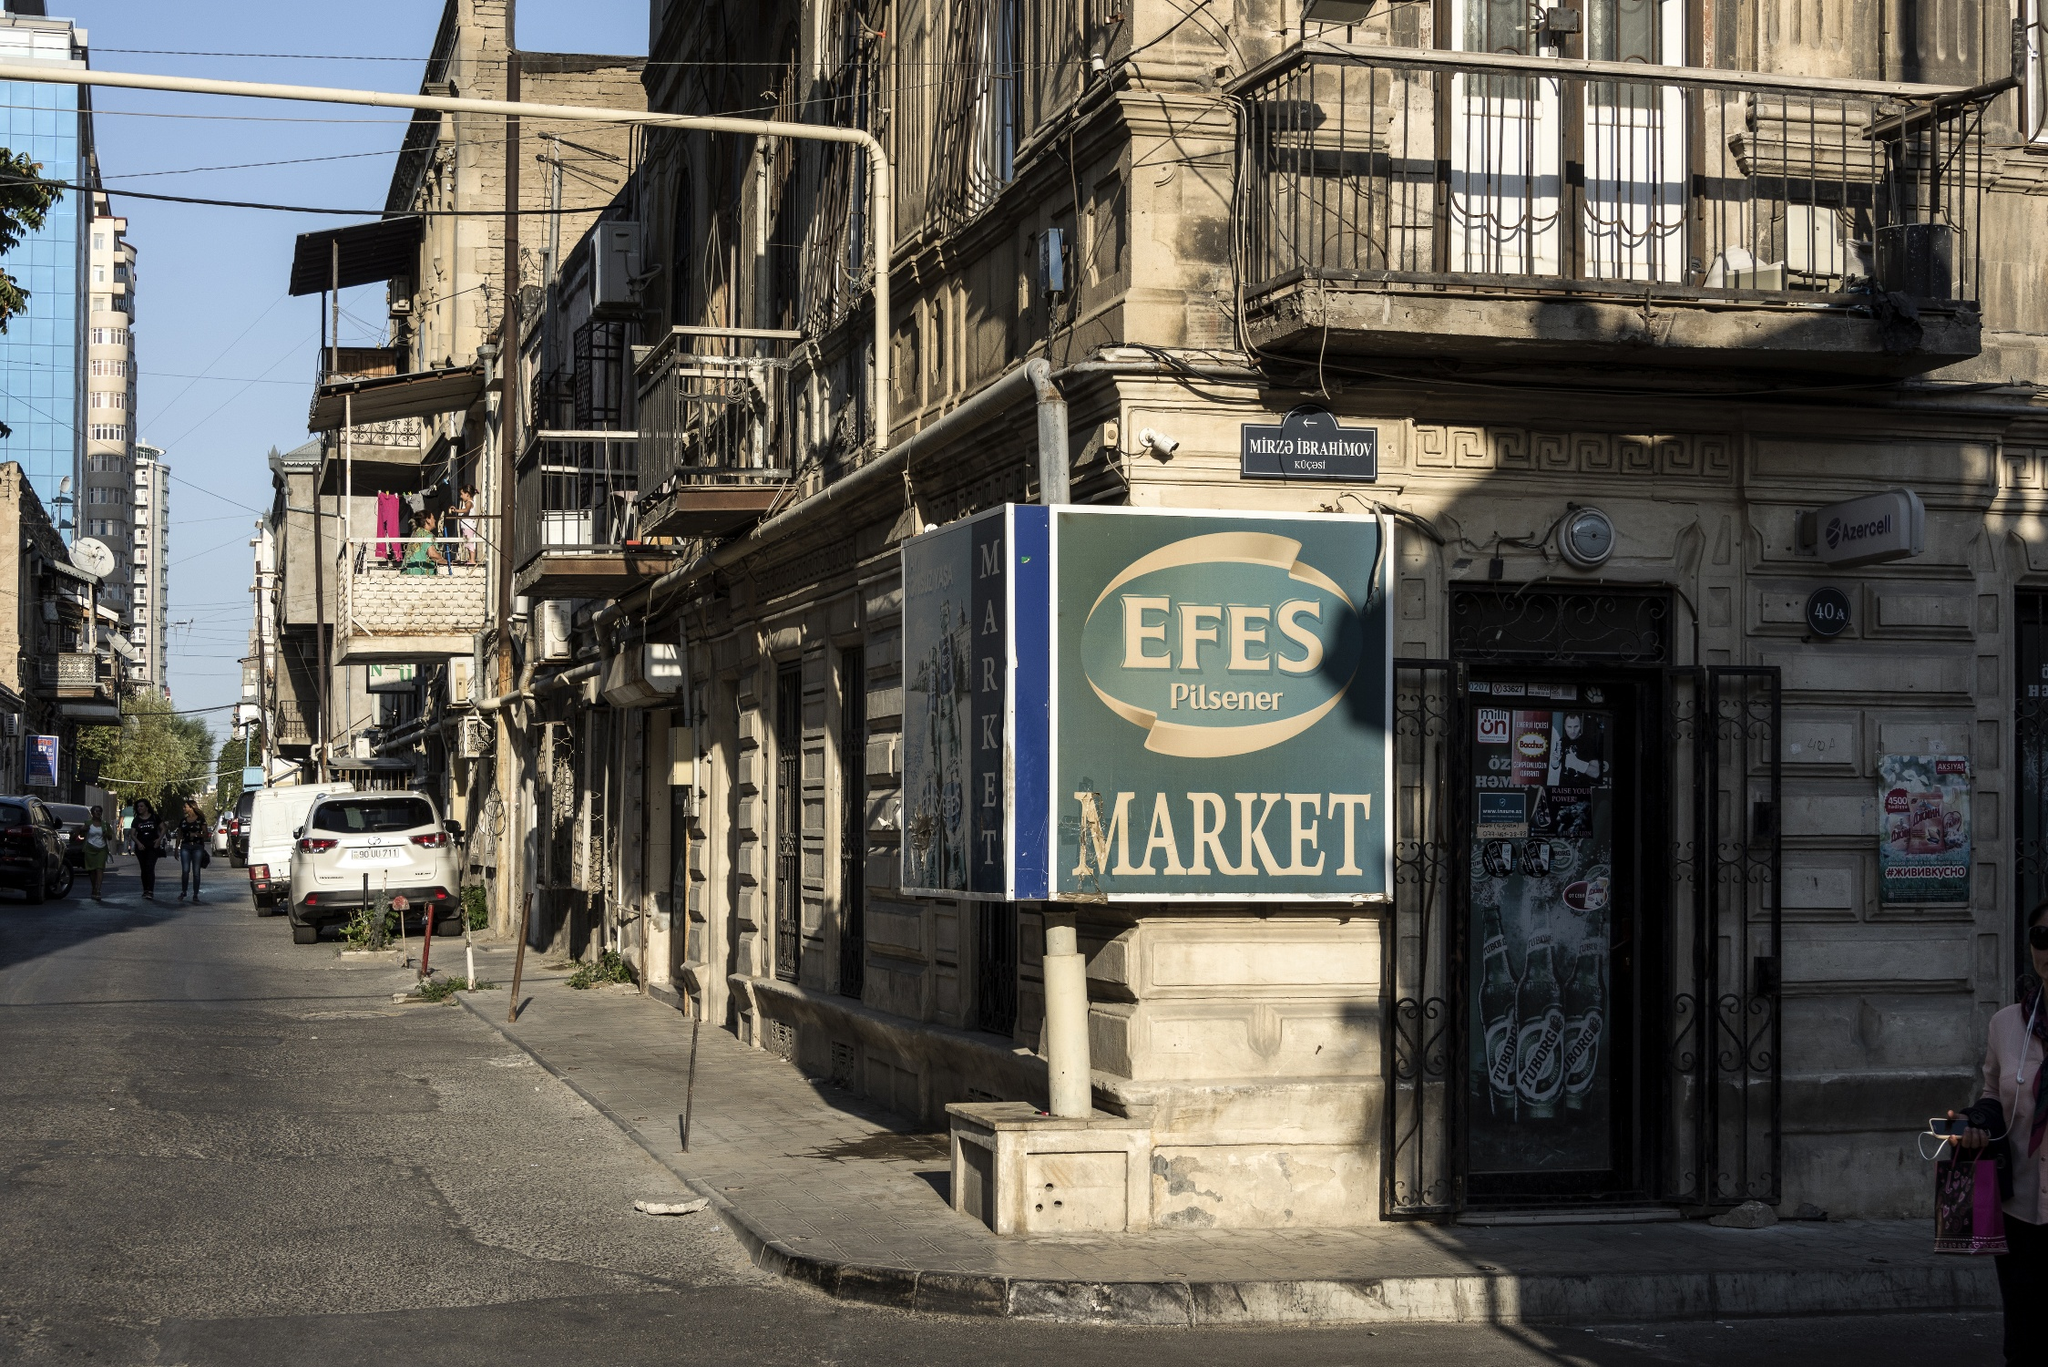You find an ancient artifact hidden in the market sign. Describe this artifact and its significance. Behind the EFES Pilsener MARKET sign, you discover an ancient artifact—a small, intricately carved wooden box. Inside the box lies an exquisitely detailed map, made of aged parchment and traced with gold ink. This map reveals hidden pathways and forgotten landmarks of the city from centuries past, offering a glimpse into a bygone era. Accompanying the map is a silver amulet inlaid with emeralds, believed to hold protective powers and worn by a legendary merchant who once traversed the ancient Silk Road. The artifact signifies the market's long-standing history as a hub of trade and cultural exchange, connecting Istanbul with the broader narratives of ancient journeys and mystical traditions. 